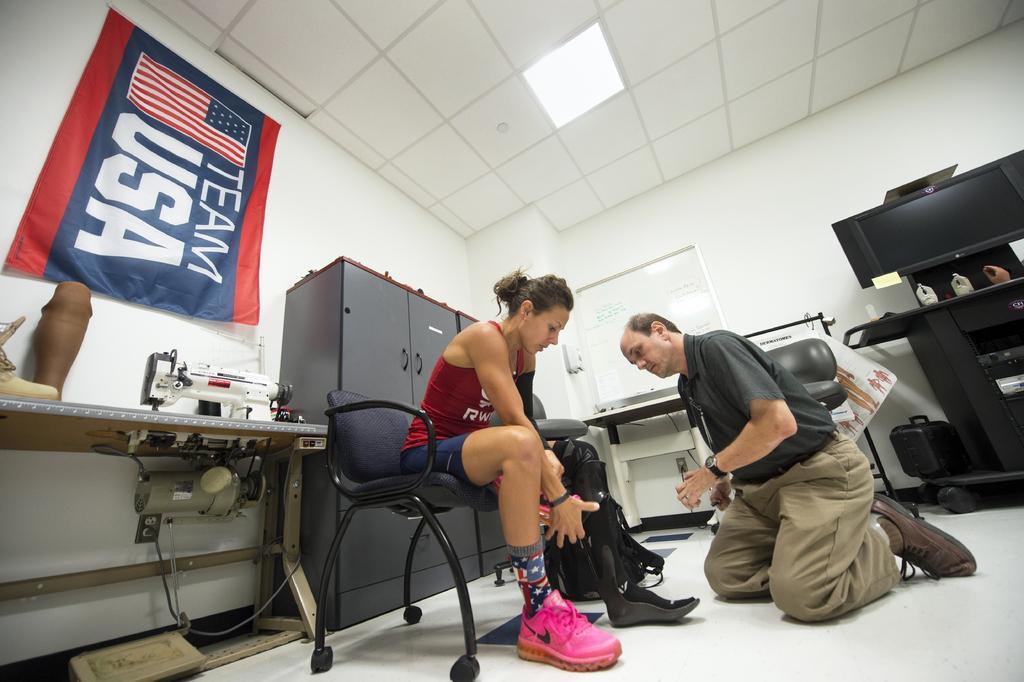Describe this image in one or two sentences. This picture might be taken inside the room. In this image, in the middle, we can see two people man and woman, and the woman is sitting on the chair, we can also see a man is in squat position. On the right side, we can see a table, on that table, we can see few toys and a television. On the left side, we can also see another table, on that table, we can see some machines, we can also see a flag which is attached to a wall. On the top, we can see a roof. 